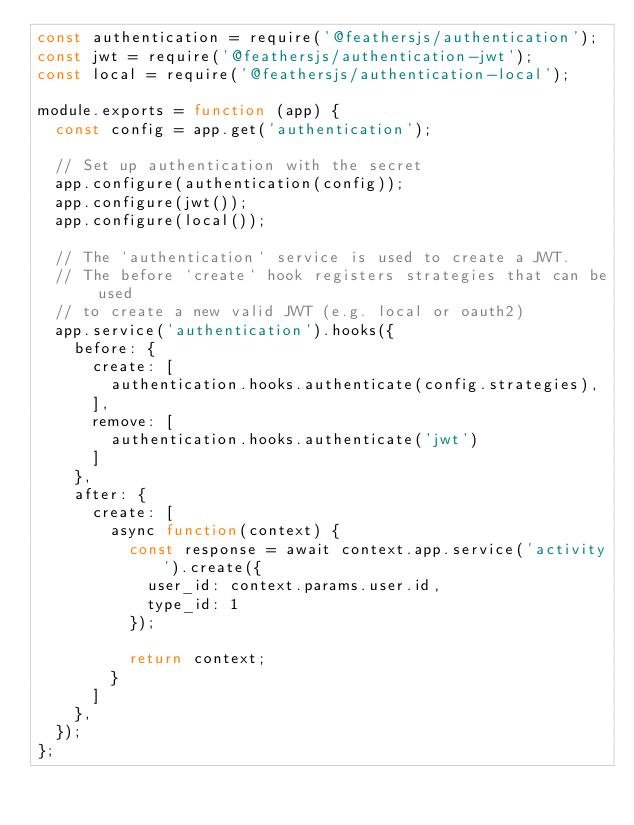<code> <loc_0><loc_0><loc_500><loc_500><_JavaScript_>const authentication = require('@feathersjs/authentication');
const jwt = require('@feathersjs/authentication-jwt');
const local = require('@feathersjs/authentication-local');

module.exports = function (app) {
  const config = app.get('authentication');

  // Set up authentication with the secret
  app.configure(authentication(config));
  app.configure(jwt());
  app.configure(local());

  // The `authentication` service is used to create a JWT.
  // The before `create` hook registers strategies that can be used
  // to create a new valid JWT (e.g. local or oauth2)
  app.service('authentication').hooks({
    before: {
      create: [
        authentication.hooks.authenticate(config.strategies),
      ],
      remove: [
        authentication.hooks.authenticate('jwt')
      ]
    },
    after: {
      create: [
        async function(context) {
          const response = await context.app.service('activity').create({ 
            user_id: context.params.user.id, 
            type_id: 1
          });

          return context;
        }
      ]
    },
  });
};
</code> 